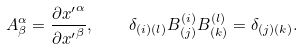<formula> <loc_0><loc_0><loc_500><loc_500>A ^ { \alpha } _ { \beta } = { \frac { \partial { x ^ { \prime } } ^ { \alpha } } { \partial { x ^ { \prime } } ^ { \beta } } } , \quad \delta _ { ( i ) ( l ) } B ^ { ( i ) } _ { ( j ) } B ^ { ( l ) } _ { ( k ) } = \delta _ { ( j ) ( k ) } .</formula> 